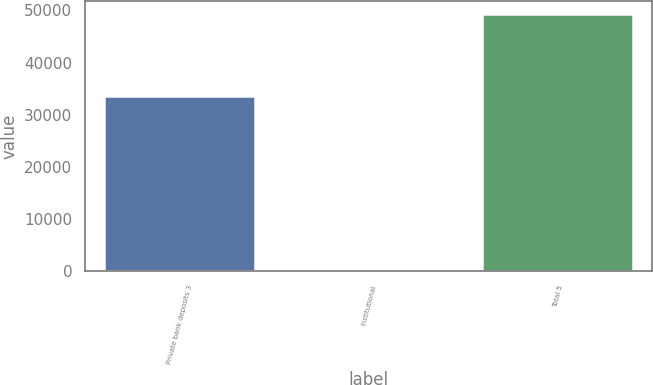Convert chart. <chart><loc_0><loc_0><loc_500><loc_500><bar_chart><fcel>Private bank deposits 3<fcel>Institutional<fcel>Total 5<nl><fcel>33590<fcel>12<fcel>49293<nl></chart> 